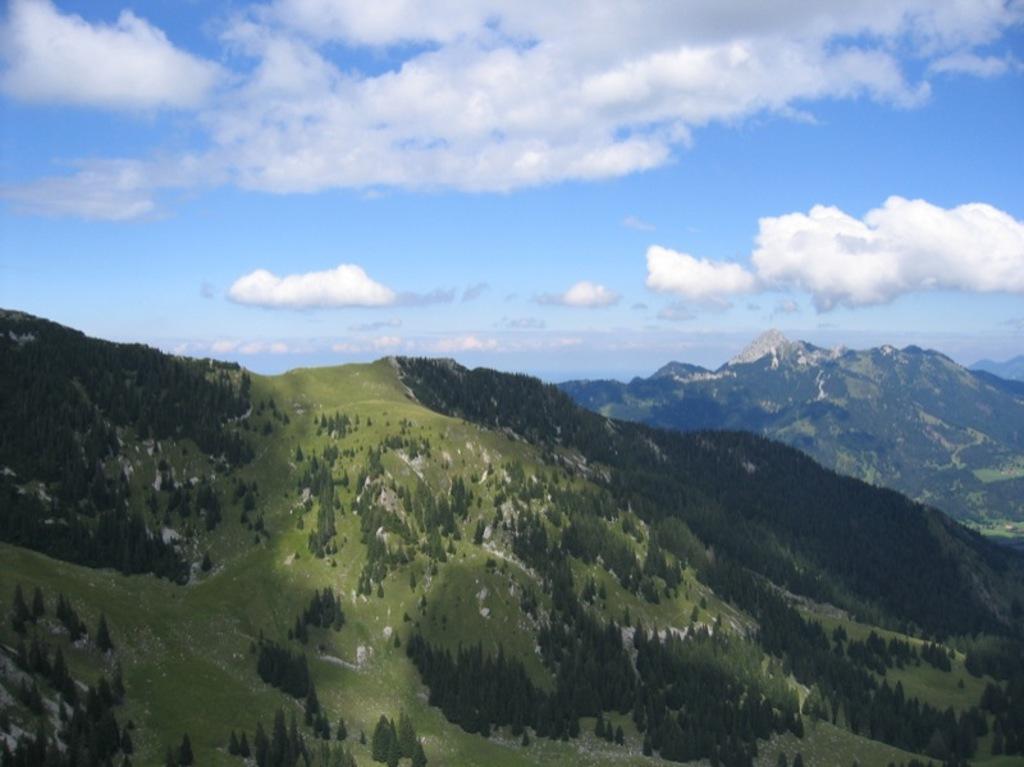Could you give a brief overview of what you see in this image? In this image there are few mountains covered with few trees and plants, some clouds in the sky. 